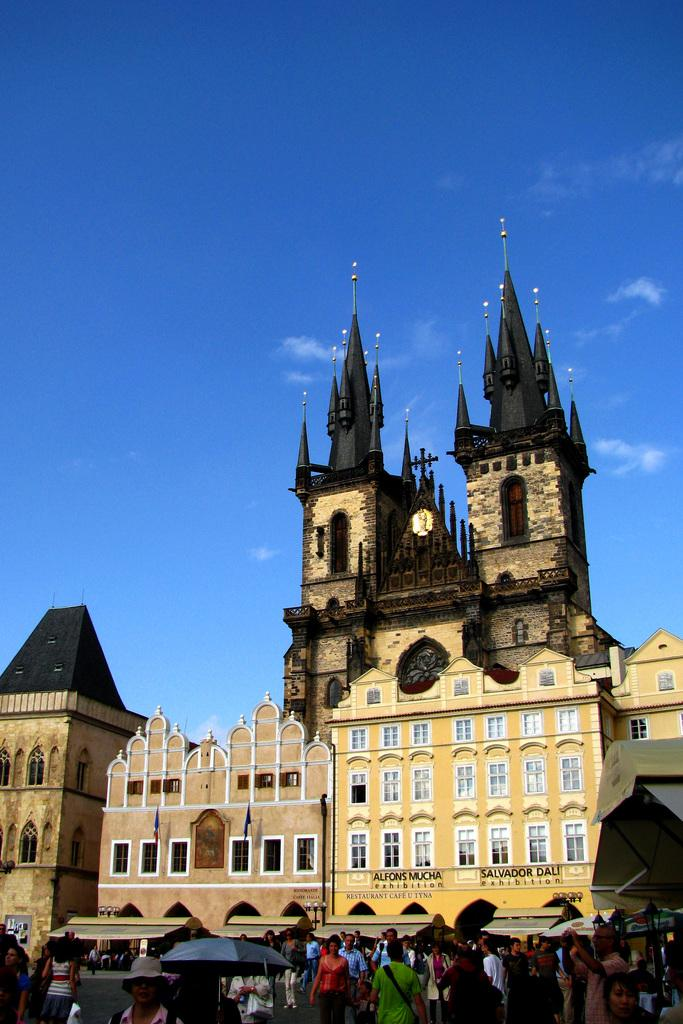Who or what can be seen in the image? There are people in the image. What structure is located in the middle of the image? There is a building in the middle of the image. What is visible at the top of the image? The sky is visible at the top of the image. What type of frame is used to hold the flesh in the image? There is no frame or flesh present in the image; it features people and a building. 